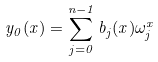Convert formula to latex. <formula><loc_0><loc_0><loc_500><loc_500>y _ { 0 } ( x ) = \sum _ { j = 0 } ^ { n - 1 } b _ { j } ( x ) \omega _ { j } ^ { x }</formula> 